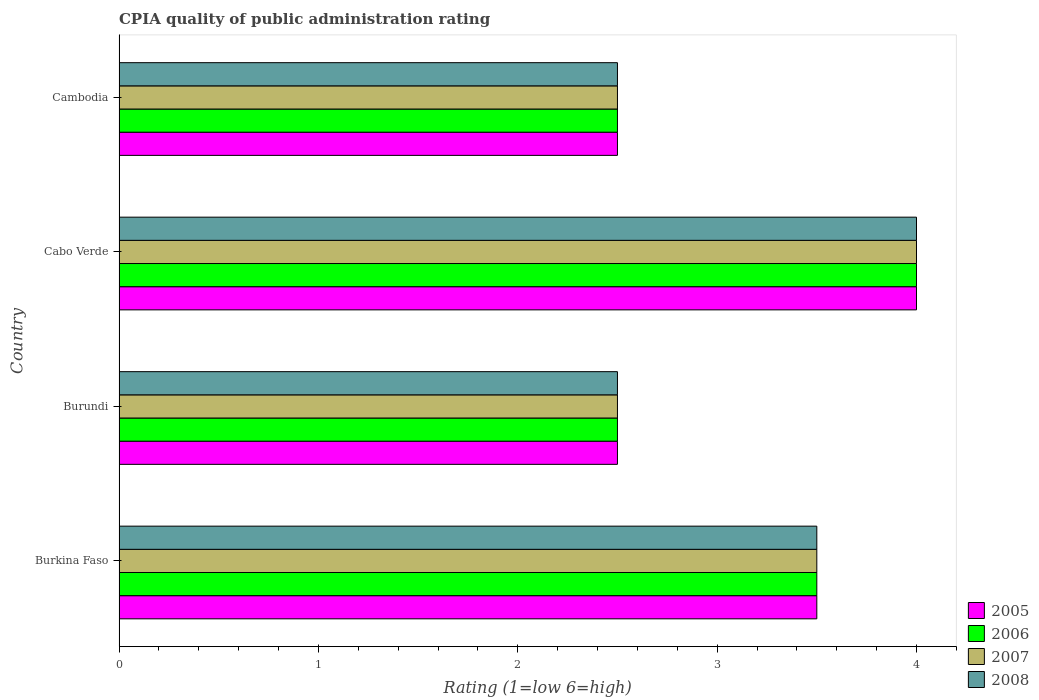How many different coloured bars are there?
Ensure brevity in your answer.  4. Are the number of bars on each tick of the Y-axis equal?
Offer a very short reply. Yes. How many bars are there on the 1st tick from the top?
Offer a terse response. 4. What is the label of the 2nd group of bars from the top?
Give a very brief answer. Cabo Verde. Across all countries, what is the minimum CPIA rating in 2008?
Your answer should be compact. 2.5. In which country was the CPIA rating in 2005 maximum?
Your answer should be very brief. Cabo Verde. In which country was the CPIA rating in 2006 minimum?
Offer a very short reply. Burundi. What is the difference between the CPIA rating in 2008 in Cabo Verde and the CPIA rating in 2005 in Burkina Faso?
Offer a very short reply. 0.5. What is the average CPIA rating in 2005 per country?
Your answer should be compact. 3.12. What is the ratio of the CPIA rating in 2007 in Cabo Verde to that in Cambodia?
Your answer should be compact. 1.6. What is the difference between the highest and the second highest CPIA rating in 2005?
Your response must be concise. 0.5. What is the difference between the highest and the lowest CPIA rating in 2007?
Your answer should be compact. 1.5. Is it the case that in every country, the sum of the CPIA rating in 2006 and CPIA rating in 2008 is greater than the sum of CPIA rating in 2007 and CPIA rating in 2005?
Provide a succinct answer. No. How many bars are there?
Provide a succinct answer. 16. Are all the bars in the graph horizontal?
Your answer should be very brief. Yes. How many countries are there in the graph?
Keep it short and to the point. 4. What is the difference between two consecutive major ticks on the X-axis?
Offer a terse response. 1. Are the values on the major ticks of X-axis written in scientific E-notation?
Keep it short and to the point. No. Does the graph contain grids?
Your answer should be very brief. No. Where does the legend appear in the graph?
Make the answer very short. Bottom right. How many legend labels are there?
Give a very brief answer. 4. How are the legend labels stacked?
Your answer should be very brief. Vertical. What is the title of the graph?
Give a very brief answer. CPIA quality of public administration rating. Does "1997" appear as one of the legend labels in the graph?
Ensure brevity in your answer.  No. What is the Rating (1=low 6=high) of 2005 in Burkina Faso?
Give a very brief answer. 3.5. What is the Rating (1=low 6=high) of 2006 in Burundi?
Your answer should be very brief. 2.5. What is the Rating (1=low 6=high) in 2008 in Burundi?
Ensure brevity in your answer.  2.5. What is the Rating (1=low 6=high) of 2005 in Cabo Verde?
Your response must be concise. 4. What is the Rating (1=low 6=high) of 2006 in Cabo Verde?
Provide a short and direct response. 4. What is the Rating (1=low 6=high) of 2007 in Cabo Verde?
Offer a terse response. 4. What is the Rating (1=low 6=high) in 2006 in Cambodia?
Ensure brevity in your answer.  2.5. What is the Rating (1=low 6=high) in 2007 in Cambodia?
Provide a succinct answer. 2.5. Across all countries, what is the maximum Rating (1=low 6=high) in 2005?
Your answer should be very brief. 4. Across all countries, what is the maximum Rating (1=low 6=high) of 2006?
Offer a terse response. 4. Across all countries, what is the maximum Rating (1=low 6=high) of 2008?
Make the answer very short. 4. Across all countries, what is the minimum Rating (1=low 6=high) in 2005?
Give a very brief answer. 2.5. Across all countries, what is the minimum Rating (1=low 6=high) of 2006?
Offer a very short reply. 2.5. Across all countries, what is the minimum Rating (1=low 6=high) of 2007?
Keep it short and to the point. 2.5. What is the total Rating (1=low 6=high) in 2005 in the graph?
Your answer should be very brief. 12.5. What is the total Rating (1=low 6=high) in 2007 in the graph?
Your response must be concise. 12.5. What is the total Rating (1=low 6=high) in 2008 in the graph?
Ensure brevity in your answer.  12.5. What is the difference between the Rating (1=low 6=high) in 2007 in Burkina Faso and that in Burundi?
Your answer should be very brief. 1. What is the difference between the Rating (1=low 6=high) in 2008 in Burkina Faso and that in Cabo Verde?
Your response must be concise. -0.5. What is the difference between the Rating (1=low 6=high) of 2007 in Burkina Faso and that in Cambodia?
Keep it short and to the point. 1. What is the difference between the Rating (1=low 6=high) in 2007 in Burundi and that in Cabo Verde?
Give a very brief answer. -1.5. What is the difference between the Rating (1=low 6=high) in 2008 in Burundi and that in Cabo Verde?
Your answer should be very brief. -1.5. What is the difference between the Rating (1=low 6=high) in 2006 in Burundi and that in Cambodia?
Your answer should be compact. 0. What is the difference between the Rating (1=low 6=high) of 2008 in Burundi and that in Cambodia?
Provide a succinct answer. 0. What is the difference between the Rating (1=low 6=high) in 2005 in Cabo Verde and that in Cambodia?
Give a very brief answer. 1.5. What is the difference between the Rating (1=low 6=high) of 2008 in Cabo Verde and that in Cambodia?
Your answer should be compact. 1.5. What is the difference between the Rating (1=low 6=high) of 2005 in Burkina Faso and the Rating (1=low 6=high) of 2006 in Burundi?
Ensure brevity in your answer.  1. What is the difference between the Rating (1=low 6=high) of 2005 in Burkina Faso and the Rating (1=low 6=high) of 2007 in Burundi?
Provide a succinct answer. 1. What is the difference between the Rating (1=low 6=high) in 2006 in Burkina Faso and the Rating (1=low 6=high) in 2007 in Burundi?
Offer a terse response. 1. What is the difference between the Rating (1=low 6=high) in 2007 in Burkina Faso and the Rating (1=low 6=high) in 2008 in Burundi?
Provide a succinct answer. 1. What is the difference between the Rating (1=low 6=high) in 2005 in Burkina Faso and the Rating (1=low 6=high) in 2006 in Cabo Verde?
Your answer should be very brief. -0.5. What is the difference between the Rating (1=low 6=high) of 2005 in Burkina Faso and the Rating (1=low 6=high) of 2007 in Cabo Verde?
Ensure brevity in your answer.  -0.5. What is the difference between the Rating (1=low 6=high) of 2006 in Burkina Faso and the Rating (1=low 6=high) of 2007 in Cabo Verde?
Ensure brevity in your answer.  -0.5. What is the difference between the Rating (1=low 6=high) in 2005 in Burkina Faso and the Rating (1=low 6=high) in 2006 in Cambodia?
Your answer should be compact. 1. What is the difference between the Rating (1=low 6=high) of 2006 in Burkina Faso and the Rating (1=low 6=high) of 2007 in Cambodia?
Your answer should be very brief. 1. What is the difference between the Rating (1=low 6=high) in 2006 in Burkina Faso and the Rating (1=low 6=high) in 2008 in Cambodia?
Offer a terse response. 1. What is the difference between the Rating (1=low 6=high) of 2007 in Burkina Faso and the Rating (1=low 6=high) of 2008 in Cambodia?
Your answer should be very brief. 1. What is the difference between the Rating (1=low 6=high) of 2005 in Burundi and the Rating (1=low 6=high) of 2006 in Cabo Verde?
Your answer should be very brief. -1.5. What is the difference between the Rating (1=low 6=high) in 2006 in Burundi and the Rating (1=low 6=high) in 2008 in Cabo Verde?
Give a very brief answer. -1.5. What is the difference between the Rating (1=low 6=high) of 2007 in Burundi and the Rating (1=low 6=high) of 2008 in Cabo Verde?
Give a very brief answer. -1.5. What is the difference between the Rating (1=low 6=high) in 2005 in Burundi and the Rating (1=low 6=high) in 2006 in Cambodia?
Your answer should be very brief. 0. What is the difference between the Rating (1=low 6=high) of 2005 in Burundi and the Rating (1=low 6=high) of 2007 in Cambodia?
Make the answer very short. 0. What is the difference between the Rating (1=low 6=high) of 2007 in Burundi and the Rating (1=low 6=high) of 2008 in Cambodia?
Offer a terse response. 0. What is the difference between the Rating (1=low 6=high) of 2005 in Cabo Verde and the Rating (1=low 6=high) of 2006 in Cambodia?
Offer a very short reply. 1.5. What is the difference between the Rating (1=low 6=high) of 2006 in Cabo Verde and the Rating (1=low 6=high) of 2007 in Cambodia?
Keep it short and to the point. 1.5. What is the average Rating (1=low 6=high) in 2005 per country?
Offer a very short reply. 3.12. What is the average Rating (1=low 6=high) in 2006 per country?
Provide a succinct answer. 3.12. What is the average Rating (1=low 6=high) in 2007 per country?
Your answer should be compact. 3.12. What is the average Rating (1=low 6=high) of 2008 per country?
Offer a terse response. 3.12. What is the difference between the Rating (1=low 6=high) of 2005 and Rating (1=low 6=high) of 2006 in Burkina Faso?
Provide a succinct answer. 0. What is the difference between the Rating (1=low 6=high) in 2005 and Rating (1=low 6=high) in 2008 in Burkina Faso?
Provide a short and direct response. 0. What is the difference between the Rating (1=low 6=high) of 2006 and Rating (1=low 6=high) of 2008 in Burkina Faso?
Your answer should be very brief. 0. What is the difference between the Rating (1=low 6=high) of 2006 and Rating (1=low 6=high) of 2007 in Burundi?
Provide a succinct answer. 0. What is the difference between the Rating (1=low 6=high) of 2005 and Rating (1=low 6=high) of 2007 in Cabo Verde?
Give a very brief answer. 0. What is the difference between the Rating (1=low 6=high) in 2006 and Rating (1=low 6=high) in 2008 in Cabo Verde?
Your response must be concise. 0. What is the difference between the Rating (1=low 6=high) of 2007 and Rating (1=low 6=high) of 2008 in Cabo Verde?
Offer a terse response. 0. What is the difference between the Rating (1=low 6=high) of 2005 and Rating (1=low 6=high) of 2006 in Cambodia?
Your response must be concise. 0. What is the difference between the Rating (1=low 6=high) in 2006 and Rating (1=low 6=high) in 2007 in Cambodia?
Your response must be concise. 0. What is the difference between the Rating (1=low 6=high) of 2006 and Rating (1=low 6=high) of 2008 in Cambodia?
Offer a terse response. 0. What is the ratio of the Rating (1=low 6=high) in 2005 in Burkina Faso to that in Burundi?
Give a very brief answer. 1.4. What is the ratio of the Rating (1=low 6=high) in 2006 in Burkina Faso to that in Burundi?
Keep it short and to the point. 1.4. What is the ratio of the Rating (1=low 6=high) of 2007 in Burkina Faso to that in Burundi?
Make the answer very short. 1.4. What is the ratio of the Rating (1=low 6=high) of 2005 in Burkina Faso to that in Cabo Verde?
Provide a short and direct response. 0.88. What is the ratio of the Rating (1=low 6=high) in 2006 in Burkina Faso to that in Cabo Verde?
Your answer should be very brief. 0.88. What is the ratio of the Rating (1=low 6=high) of 2007 in Burkina Faso to that in Cabo Verde?
Ensure brevity in your answer.  0.88. What is the ratio of the Rating (1=low 6=high) in 2005 in Burkina Faso to that in Cambodia?
Your answer should be compact. 1.4. What is the ratio of the Rating (1=low 6=high) in 2006 in Burkina Faso to that in Cambodia?
Your response must be concise. 1.4. What is the ratio of the Rating (1=low 6=high) in 2005 in Burundi to that in Cabo Verde?
Provide a short and direct response. 0.62. What is the ratio of the Rating (1=low 6=high) in 2006 in Burundi to that in Cabo Verde?
Provide a succinct answer. 0.62. What is the ratio of the Rating (1=low 6=high) in 2006 in Burundi to that in Cambodia?
Keep it short and to the point. 1. What is the ratio of the Rating (1=low 6=high) of 2007 in Burundi to that in Cambodia?
Ensure brevity in your answer.  1. What is the ratio of the Rating (1=low 6=high) in 2008 in Burundi to that in Cambodia?
Offer a very short reply. 1. What is the ratio of the Rating (1=low 6=high) of 2006 in Cabo Verde to that in Cambodia?
Make the answer very short. 1.6. What is the ratio of the Rating (1=low 6=high) in 2007 in Cabo Verde to that in Cambodia?
Your answer should be compact. 1.6. What is the ratio of the Rating (1=low 6=high) in 2008 in Cabo Verde to that in Cambodia?
Provide a short and direct response. 1.6. What is the difference between the highest and the second highest Rating (1=low 6=high) in 2008?
Make the answer very short. 0.5. What is the difference between the highest and the lowest Rating (1=low 6=high) in 2008?
Ensure brevity in your answer.  1.5. 